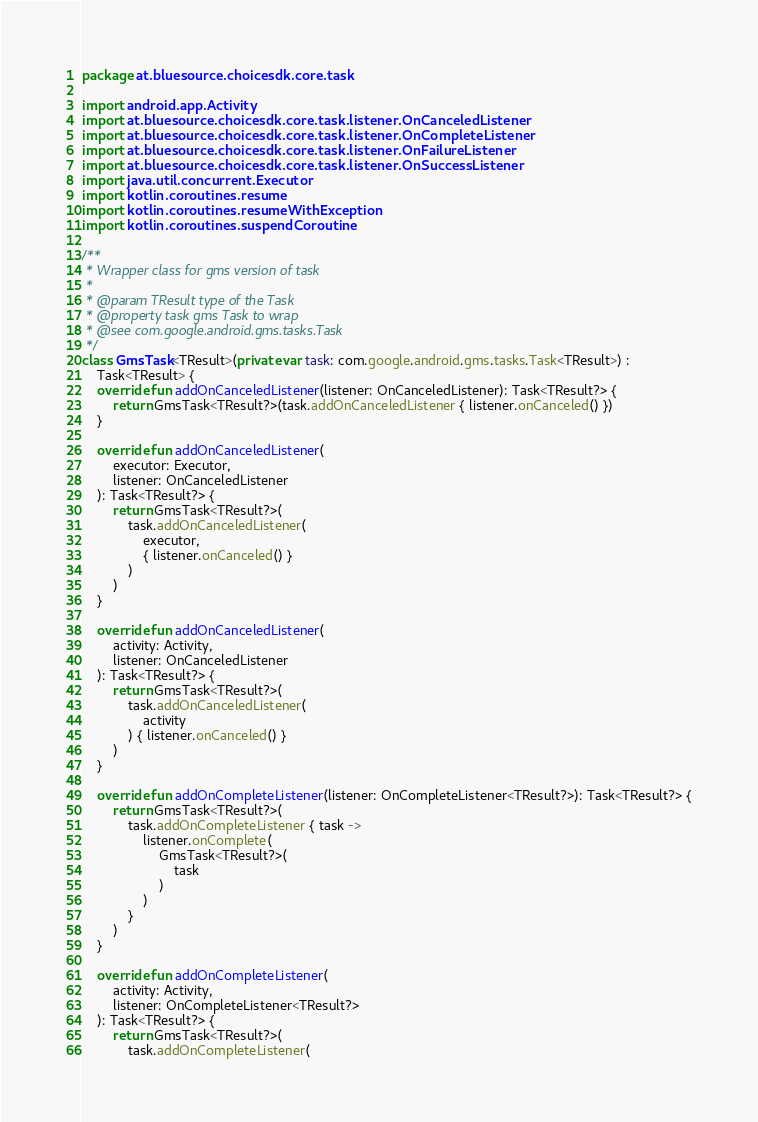Convert code to text. <code><loc_0><loc_0><loc_500><loc_500><_Kotlin_>package at.bluesource.choicesdk.core.task

import android.app.Activity
import at.bluesource.choicesdk.core.task.listener.OnCanceledListener
import at.bluesource.choicesdk.core.task.listener.OnCompleteListener
import at.bluesource.choicesdk.core.task.listener.OnFailureListener
import at.bluesource.choicesdk.core.task.listener.OnSuccessListener
import java.util.concurrent.Executor
import kotlin.coroutines.resume
import kotlin.coroutines.resumeWithException
import kotlin.coroutines.suspendCoroutine

/**
 * Wrapper class for gms version of task
 *
 * @param TResult type of the Task
 * @property task gms Task to wrap
 * @see com.google.android.gms.tasks.Task
 */
class GmsTask<TResult>(private var task: com.google.android.gms.tasks.Task<TResult>) :
    Task<TResult> {
    override fun addOnCanceledListener(listener: OnCanceledListener): Task<TResult?> {
        return GmsTask<TResult?>(task.addOnCanceledListener { listener.onCanceled() })
    }

    override fun addOnCanceledListener(
        executor: Executor,
        listener: OnCanceledListener
    ): Task<TResult?> {
        return GmsTask<TResult?>(
            task.addOnCanceledListener(
                executor,
                { listener.onCanceled() }
            )
        )
    }

    override fun addOnCanceledListener(
        activity: Activity,
        listener: OnCanceledListener
    ): Task<TResult?> {
        return GmsTask<TResult?>(
            task.addOnCanceledListener(
                activity
            ) { listener.onCanceled() }
        )
    }

    override fun addOnCompleteListener(listener: OnCompleteListener<TResult?>): Task<TResult?> {
        return GmsTask<TResult?>(
            task.addOnCompleteListener { task ->
                listener.onComplete(
                    GmsTask<TResult?>(
                        task
                    )
                )
            }
        )
    }

    override fun addOnCompleteListener(
        activity: Activity,
        listener: OnCompleteListener<TResult?>
    ): Task<TResult?> {
        return GmsTask<TResult?>(
            task.addOnCompleteListener(</code> 